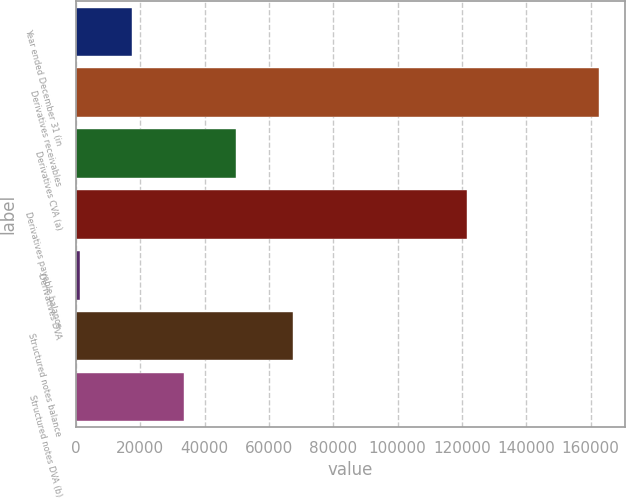Convert chart. <chart><loc_0><loc_0><loc_500><loc_500><bar_chart><fcel>Year ended December 31 (in<fcel>Derivatives receivables<fcel>Derivatives CVA (a)<fcel>Derivatives payable balance<fcel>Derivatives DVA<fcel>Structured notes balance<fcel>Structured notes DVA (b)<nl><fcel>17512.7<fcel>162626<fcel>49760.1<fcel>121604<fcel>1389<fcel>67340<fcel>33636.4<nl></chart> 